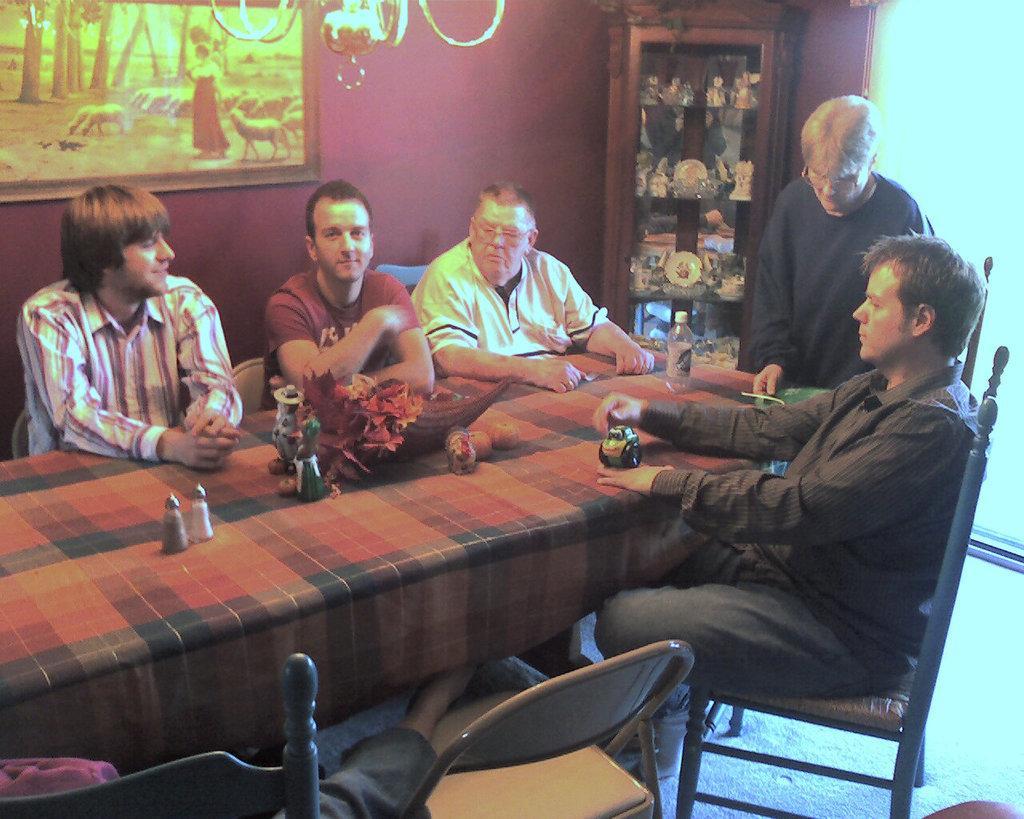Please provide a concise description of this image. In this picture we can see a group of men where some are sitting on chairs and one is standing and on table we can see leaves, jar, bottles and in background we can see wall with frames, racks with glass items in it. 